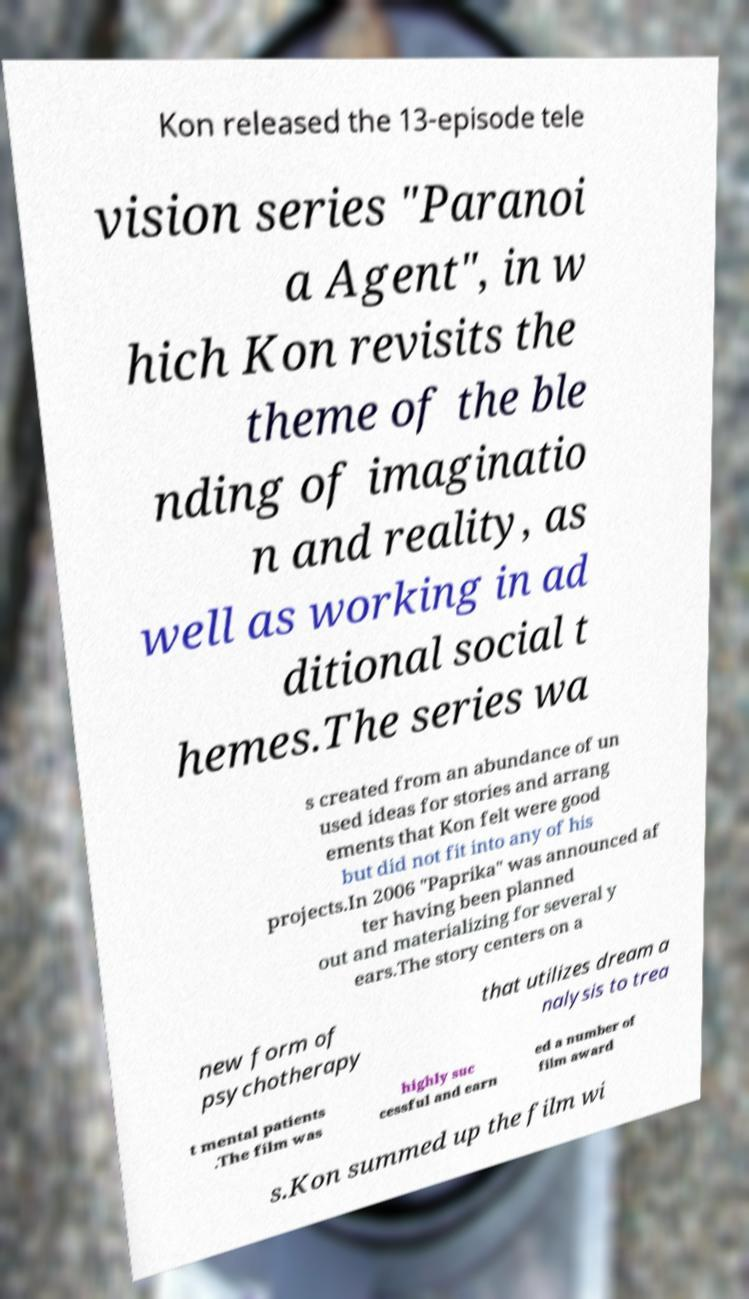For documentation purposes, I need the text within this image transcribed. Could you provide that? Kon released the 13-episode tele vision series "Paranoi a Agent", in w hich Kon revisits the theme of the ble nding of imaginatio n and reality, as well as working in ad ditional social t hemes.The series wa s created from an abundance of un used ideas for stories and arrang ements that Kon felt were good but did not fit into any of his projects.In 2006 "Paprika" was announced af ter having been planned out and materializing for several y ears.The story centers on a new form of psychotherapy that utilizes dream a nalysis to trea t mental patients .The film was highly suc cessful and earn ed a number of film award s.Kon summed up the film wi 